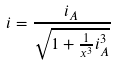Convert formula to latex. <formula><loc_0><loc_0><loc_500><loc_500>i = \frac { i _ { A } } { \sqrt { 1 + \frac { 1 } { x ^ { 3 } } i _ { A } ^ { 3 } } }</formula> 